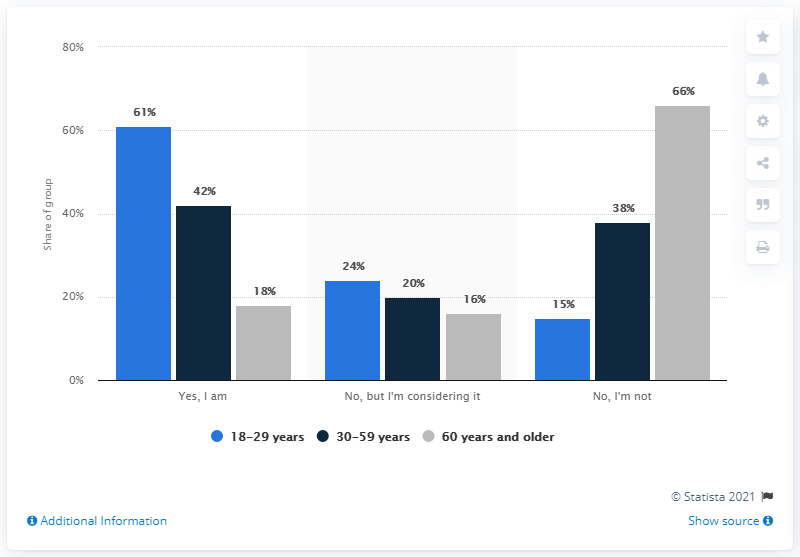Highlight a few significant elements in this photo. The highest bar in the chart represents approximately 66% of the total. The average of "Yes, I am" bars is approximately 40.33. 